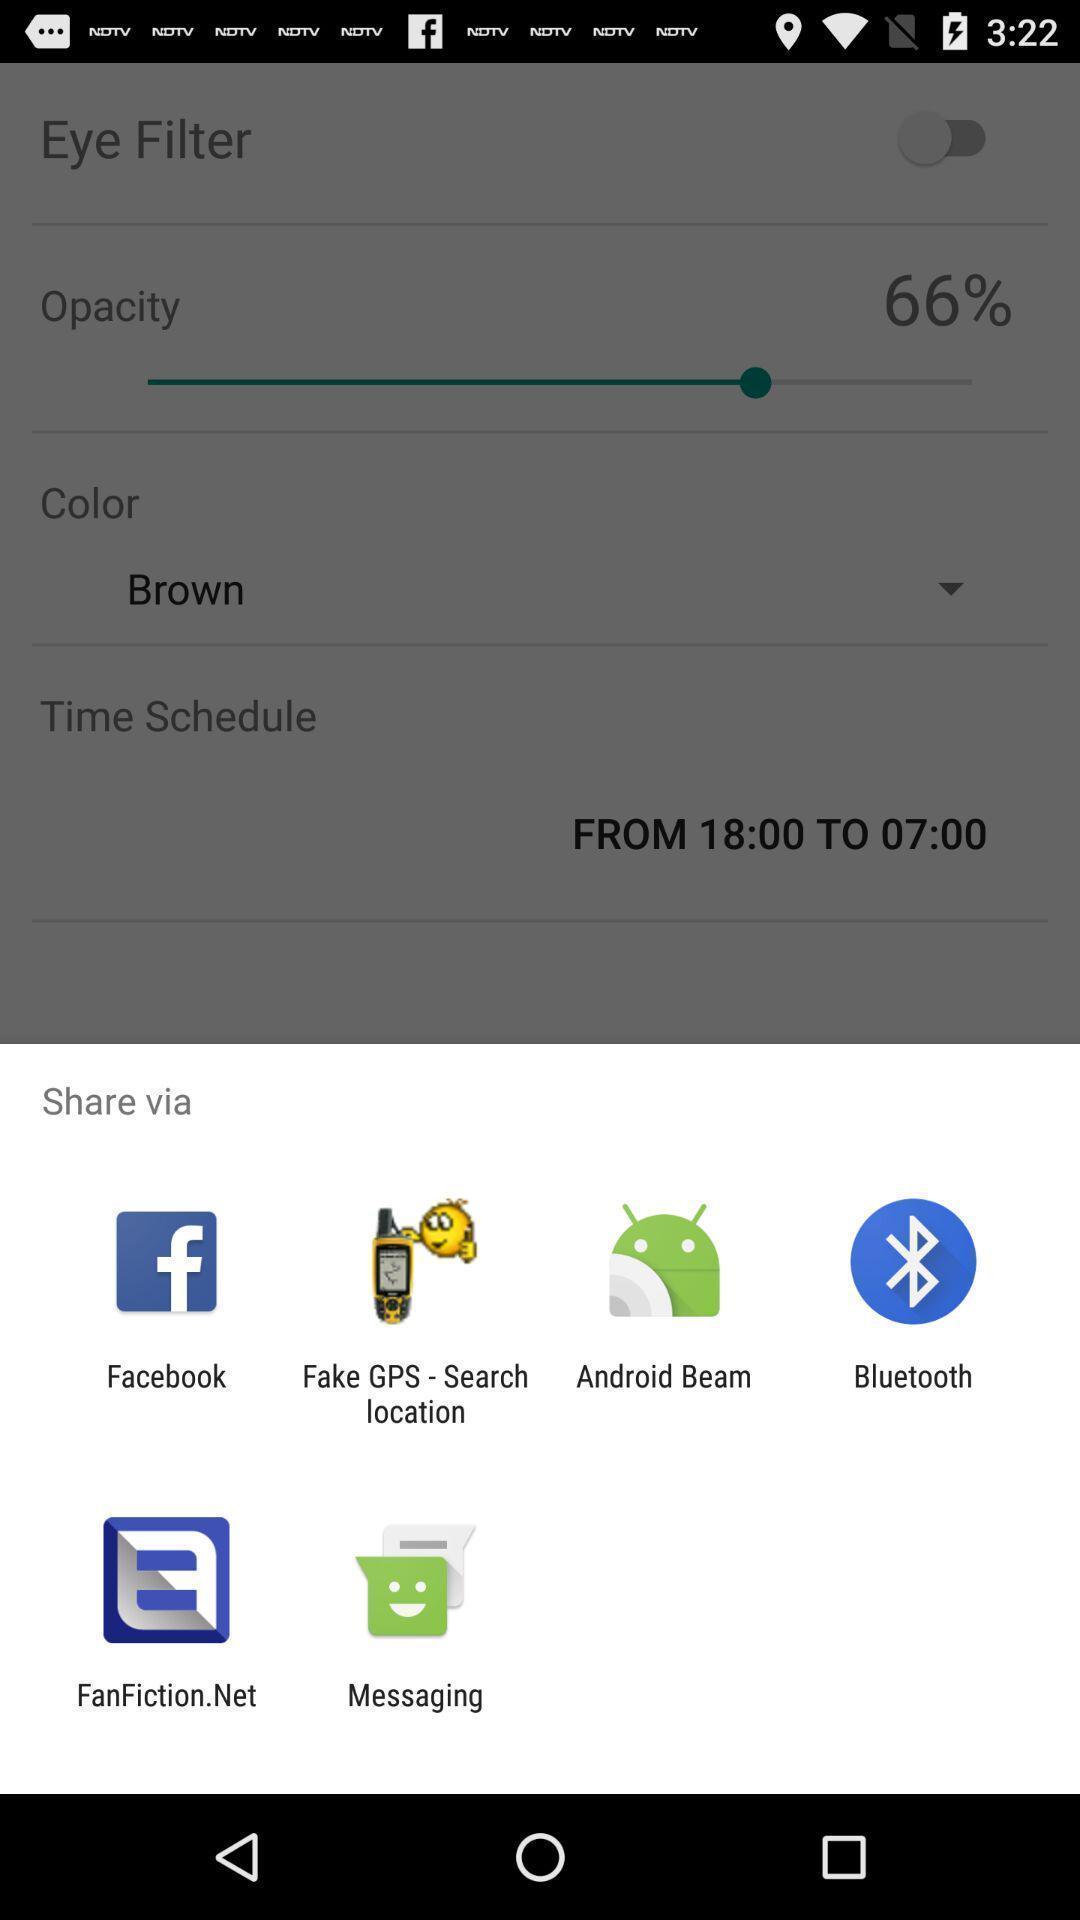Summarize the information in this screenshot. Sharing options in a mobile. 